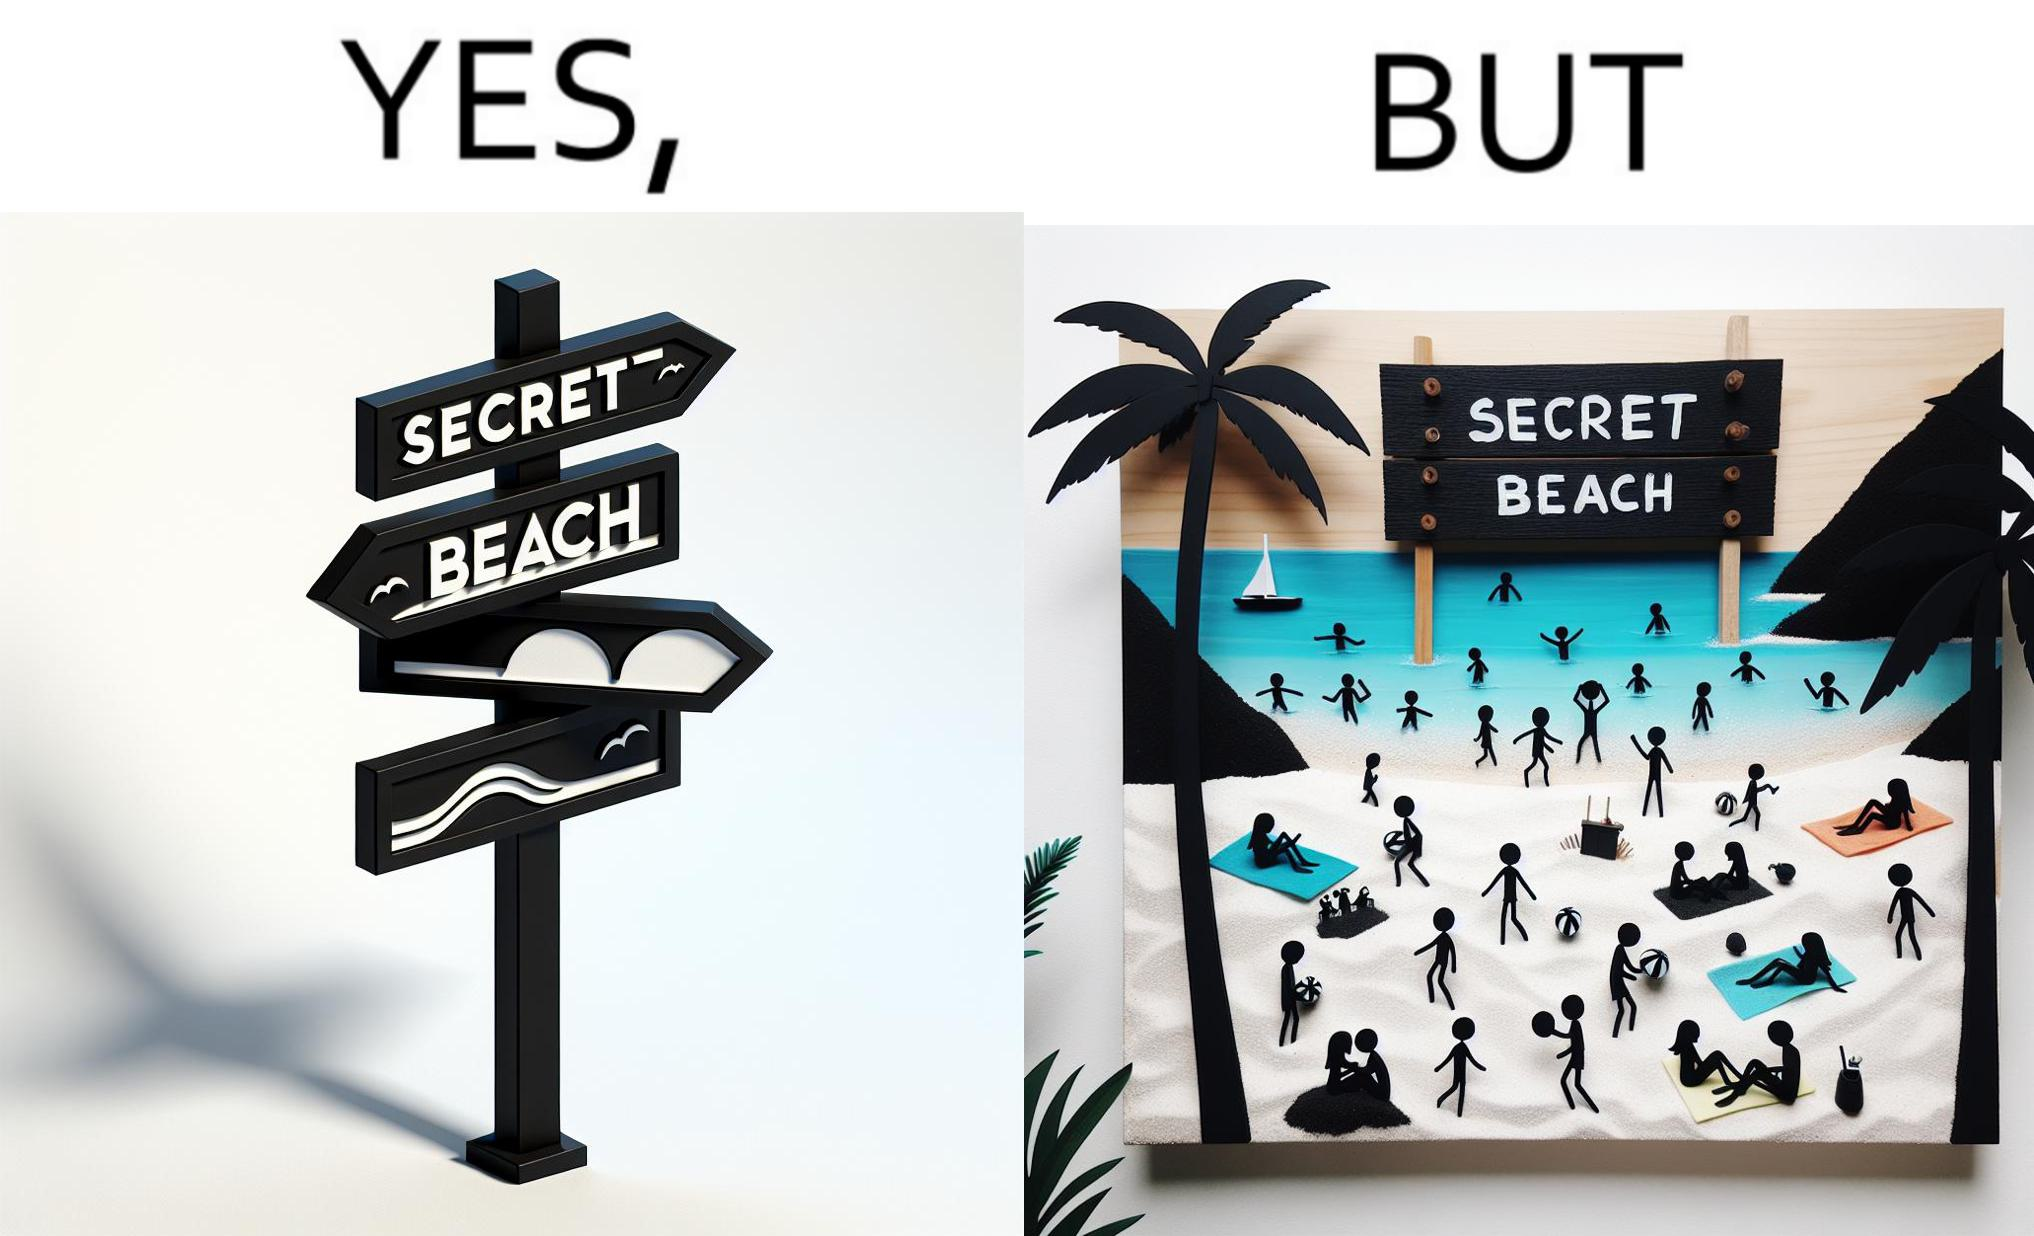Describe the contrast between the left and right parts of this image. In the left part of the image: A board with "Secret Beach" written on it. In the right part of the image: People in a beach, having a board with "Secret Beach" written on it at its entrance. 